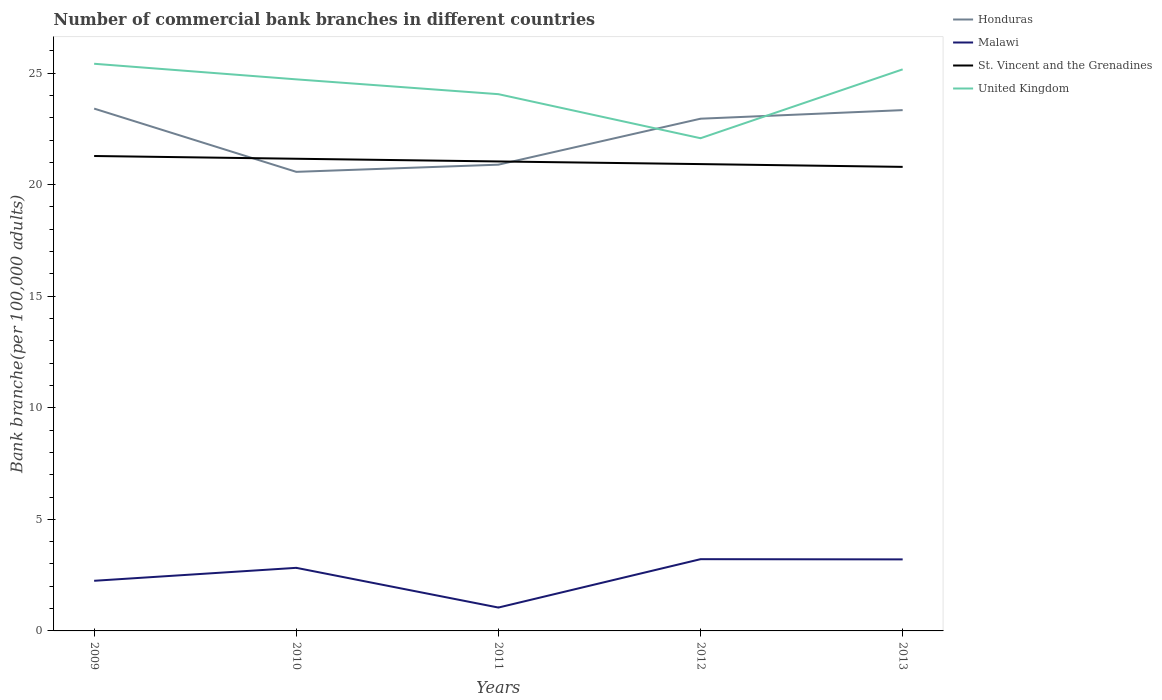Does the line corresponding to United Kingdom intersect with the line corresponding to Malawi?
Offer a very short reply. No. Across all years, what is the maximum number of commercial bank branches in Honduras?
Provide a succinct answer. 20.57. What is the total number of commercial bank branches in St. Vincent and the Grenadines in the graph?
Your answer should be compact. 0.24. What is the difference between the highest and the second highest number of commercial bank branches in United Kingdom?
Provide a succinct answer. 3.34. What is the difference between the highest and the lowest number of commercial bank branches in Honduras?
Provide a succinct answer. 3. Is the number of commercial bank branches in St. Vincent and the Grenadines strictly greater than the number of commercial bank branches in Malawi over the years?
Give a very brief answer. No. How many lines are there?
Your answer should be very brief. 4. What is the difference between two consecutive major ticks on the Y-axis?
Offer a terse response. 5. Are the values on the major ticks of Y-axis written in scientific E-notation?
Keep it short and to the point. No. Does the graph contain grids?
Your answer should be very brief. No. What is the title of the graph?
Provide a succinct answer. Number of commercial bank branches in different countries. Does "Estonia" appear as one of the legend labels in the graph?
Provide a short and direct response. No. What is the label or title of the X-axis?
Ensure brevity in your answer.  Years. What is the label or title of the Y-axis?
Offer a very short reply. Bank branche(per 100,0 adults). What is the Bank branche(per 100,000 adults) of Honduras in 2009?
Provide a succinct answer. 23.41. What is the Bank branche(per 100,000 adults) of Malawi in 2009?
Offer a very short reply. 2.25. What is the Bank branche(per 100,000 adults) in St. Vincent and the Grenadines in 2009?
Offer a terse response. 21.28. What is the Bank branche(per 100,000 adults) in United Kingdom in 2009?
Your answer should be compact. 25.42. What is the Bank branche(per 100,000 adults) of Honduras in 2010?
Make the answer very short. 20.57. What is the Bank branche(per 100,000 adults) of Malawi in 2010?
Your answer should be very brief. 2.83. What is the Bank branche(per 100,000 adults) of St. Vincent and the Grenadines in 2010?
Provide a succinct answer. 21.16. What is the Bank branche(per 100,000 adults) of United Kingdom in 2010?
Offer a terse response. 24.72. What is the Bank branche(per 100,000 adults) of Honduras in 2011?
Offer a terse response. 20.89. What is the Bank branche(per 100,000 adults) of Malawi in 2011?
Provide a short and direct response. 1.05. What is the Bank branche(per 100,000 adults) of St. Vincent and the Grenadines in 2011?
Your response must be concise. 21.04. What is the Bank branche(per 100,000 adults) in United Kingdom in 2011?
Make the answer very short. 24.05. What is the Bank branche(per 100,000 adults) of Honduras in 2012?
Ensure brevity in your answer.  22.95. What is the Bank branche(per 100,000 adults) of Malawi in 2012?
Provide a short and direct response. 3.22. What is the Bank branche(per 100,000 adults) in St. Vincent and the Grenadines in 2012?
Offer a very short reply. 20.92. What is the Bank branche(per 100,000 adults) in United Kingdom in 2012?
Provide a short and direct response. 22.08. What is the Bank branche(per 100,000 adults) in Honduras in 2013?
Provide a succinct answer. 23.34. What is the Bank branche(per 100,000 adults) in Malawi in 2013?
Provide a short and direct response. 3.21. What is the Bank branche(per 100,000 adults) of St. Vincent and the Grenadines in 2013?
Make the answer very short. 20.8. What is the Bank branche(per 100,000 adults) in United Kingdom in 2013?
Your response must be concise. 25.17. Across all years, what is the maximum Bank branche(per 100,000 adults) of Honduras?
Offer a very short reply. 23.41. Across all years, what is the maximum Bank branche(per 100,000 adults) of Malawi?
Offer a very short reply. 3.22. Across all years, what is the maximum Bank branche(per 100,000 adults) of St. Vincent and the Grenadines?
Your answer should be compact. 21.28. Across all years, what is the maximum Bank branche(per 100,000 adults) of United Kingdom?
Keep it short and to the point. 25.42. Across all years, what is the minimum Bank branche(per 100,000 adults) in Honduras?
Provide a short and direct response. 20.57. Across all years, what is the minimum Bank branche(per 100,000 adults) in Malawi?
Your answer should be compact. 1.05. Across all years, what is the minimum Bank branche(per 100,000 adults) in St. Vincent and the Grenadines?
Your answer should be very brief. 20.8. Across all years, what is the minimum Bank branche(per 100,000 adults) of United Kingdom?
Your answer should be very brief. 22.08. What is the total Bank branche(per 100,000 adults) of Honduras in the graph?
Provide a succinct answer. 111.17. What is the total Bank branche(per 100,000 adults) in Malawi in the graph?
Ensure brevity in your answer.  12.54. What is the total Bank branche(per 100,000 adults) in St. Vincent and the Grenadines in the graph?
Your answer should be very brief. 105.2. What is the total Bank branche(per 100,000 adults) in United Kingdom in the graph?
Ensure brevity in your answer.  121.44. What is the difference between the Bank branche(per 100,000 adults) in Honduras in 2009 and that in 2010?
Your response must be concise. 2.83. What is the difference between the Bank branche(per 100,000 adults) of Malawi in 2009 and that in 2010?
Offer a terse response. -0.58. What is the difference between the Bank branche(per 100,000 adults) of St. Vincent and the Grenadines in 2009 and that in 2010?
Your response must be concise. 0.12. What is the difference between the Bank branche(per 100,000 adults) in United Kingdom in 2009 and that in 2010?
Provide a succinct answer. 0.7. What is the difference between the Bank branche(per 100,000 adults) of Honduras in 2009 and that in 2011?
Provide a short and direct response. 2.51. What is the difference between the Bank branche(per 100,000 adults) in Malawi in 2009 and that in 2011?
Your answer should be very brief. 1.2. What is the difference between the Bank branche(per 100,000 adults) of St. Vincent and the Grenadines in 2009 and that in 2011?
Make the answer very short. 0.24. What is the difference between the Bank branche(per 100,000 adults) in United Kingdom in 2009 and that in 2011?
Your answer should be very brief. 1.36. What is the difference between the Bank branche(per 100,000 adults) of Honduras in 2009 and that in 2012?
Your answer should be very brief. 0.45. What is the difference between the Bank branche(per 100,000 adults) in Malawi in 2009 and that in 2012?
Keep it short and to the point. -0.97. What is the difference between the Bank branche(per 100,000 adults) in St. Vincent and the Grenadines in 2009 and that in 2012?
Your answer should be very brief. 0.36. What is the difference between the Bank branche(per 100,000 adults) of United Kingdom in 2009 and that in 2012?
Your answer should be compact. 3.34. What is the difference between the Bank branche(per 100,000 adults) in Honduras in 2009 and that in 2013?
Make the answer very short. 0.07. What is the difference between the Bank branche(per 100,000 adults) in Malawi in 2009 and that in 2013?
Provide a succinct answer. -0.96. What is the difference between the Bank branche(per 100,000 adults) of St. Vincent and the Grenadines in 2009 and that in 2013?
Ensure brevity in your answer.  0.49. What is the difference between the Bank branche(per 100,000 adults) in United Kingdom in 2009 and that in 2013?
Provide a succinct answer. 0.25. What is the difference between the Bank branche(per 100,000 adults) of Honduras in 2010 and that in 2011?
Keep it short and to the point. -0.32. What is the difference between the Bank branche(per 100,000 adults) in Malawi in 2010 and that in 2011?
Ensure brevity in your answer.  1.78. What is the difference between the Bank branche(per 100,000 adults) in St. Vincent and the Grenadines in 2010 and that in 2011?
Ensure brevity in your answer.  0.12. What is the difference between the Bank branche(per 100,000 adults) in United Kingdom in 2010 and that in 2011?
Make the answer very short. 0.66. What is the difference between the Bank branche(per 100,000 adults) of Honduras in 2010 and that in 2012?
Keep it short and to the point. -2.38. What is the difference between the Bank branche(per 100,000 adults) of Malawi in 2010 and that in 2012?
Your response must be concise. -0.39. What is the difference between the Bank branche(per 100,000 adults) of St. Vincent and the Grenadines in 2010 and that in 2012?
Offer a very short reply. 0.24. What is the difference between the Bank branche(per 100,000 adults) in United Kingdom in 2010 and that in 2012?
Keep it short and to the point. 2.64. What is the difference between the Bank branche(per 100,000 adults) of Honduras in 2010 and that in 2013?
Make the answer very short. -2.77. What is the difference between the Bank branche(per 100,000 adults) in Malawi in 2010 and that in 2013?
Offer a terse response. -0.38. What is the difference between the Bank branche(per 100,000 adults) in St. Vincent and the Grenadines in 2010 and that in 2013?
Provide a succinct answer. 0.36. What is the difference between the Bank branche(per 100,000 adults) in United Kingdom in 2010 and that in 2013?
Keep it short and to the point. -0.45. What is the difference between the Bank branche(per 100,000 adults) in Honduras in 2011 and that in 2012?
Ensure brevity in your answer.  -2.06. What is the difference between the Bank branche(per 100,000 adults) in Malawi in 2011 and that in 2012?
Offer a very short reply. -2.17. What is the difference between the Bank branche(per 100,000 adults) of St. Vincent and the Grenadines in 2011 and that in 2012?
Your answer should be very brief. 0.12. What is the difference between the Bank branche(per 100,000 adults) in United Kingdom in 2011 and that in 2012?
Your answer should be compact. 1.97. What is the difference between the Bank branche(per 100,000 adults) in Honduras in 2011 and that in 2013?
Your answer should be very brief. -2.44. What is the difference between the Bank branche(per 100,000 adults) of Malawi in 2011 and that in 2013?
Make the answer very short. -2.16. What is the difference between the Bank branche(per 100,000 adults) of St. Vincent and the Grenadines in 2011 and that in 2013?
Provide a succinct answer. 0.24. What is the difference between the Bank branche(per 100,000 adults) of United Kingdom in 2011 and that in 2013?
Provide a short and direct response. -1.11. What is the difference between the Bank branche(per 100,000 adults) of Honduras in 2012 and that in 2013?
Your response must be concise. -0.38. What is the difference between the Bank branche(per 100,000 adults) of Malawi in 2012 and that in 2013?
Keep it short and to the point. 0.01. What is the difference between the Bank branche(per 100,000 adults) of St. Vincent and the Grenadines in 2012 and that in 2013?
Your answer should be compact. 0.12. What is the difference between the Bank branche(per 100,000 adults) of United Kingdom in 2012 and that in 2013?
Provide a short and direct response. -3.09. What is the difference between the Bank branche(per 100,000 adults) of Honduras in 2009 and the Bank branche(per 100,000 adults) of Malawi in 2010?
Ensure brevity in your answer.  20.58. What is the difference between the Bank branche(per 100,000 adults) of Honduras in 2009 and the Bank branche(per 100,000 adults) of St. Vincent and the Grenadines in 2010?
Give a very brief answer. 2.25. What is the difference between the Bank branche(per 100,000 adults) in Honduras in 2009 and the Bank branche(per 100,000 adults) in United Kingdom in 2010?
Offer a very short reply. -1.31. What is the difference between the Bank branche(per 100,000 adults) of Malawi in 2009 and the Bank branche(per 100,000 adults) of St. Vincent and the Grenadines in 2010?
Your answer should be compact. -18.91. What is the difference between the Bank branche(per 100,000 adults) in Malawi in 2009 and the Bank branche(per 100,000 adults) in United Kingdom in 2010?
Provide a succinct answer. -22.47. What is the difference between the Bank branche(per 100,000 adults) in St. Vincent and the Grenadines in 2009 and the Bank branche(per 100,000 adults) in United Kingdom in 2010?
Provide a succinct answer. -3.44. What is the difference between the Bank branche(per 100,000 adults) of Honduras in 2009 and the Bank branche(per 100,000 adults) of Malawi in 2011?
Your answer should be compact. 22.36. What is the difference between the Bank branche(per 100,000 adults) in Honduras in 2009 and the Bank branche(per 100,000 adults) in St. Vincent and the Grenadines in 2011?
Your answer should be compact. 2.37. What is the difference between the Bank branche(per 100,000 adults) of Honduras in 2009 and the Bank branche(per 100,000 adults) of United Kingdom in 2011?
Provide a succinct answer. -0.65. What is the difference between the Bank branche(per 100,000 adults) in Malawi in 2009 and the Bank branche(per 100,000 adults) in St. Vincent and the Grenadines in 2011?
Give a very brief answer. -18.79. What is the difference between the Bank branche(per 100,000 adults) in Malawi in 2009 and the Bank branche(per 100,000 adults) in United Kingdom in 2011?
Ensure brevity in your answer.  -21.81. What is the difference between the Bank branche(per 100,000 adults) in St. Vincent and the Grenadines in 2009 and the Bank branche(per 100,000 adults) in United Kingdom in 2011?
Make the answer very short. -2.77. What is the difference between the Bank branche(per 100,000 adults) in Honduras in 2009 and the Bank branche(per 100,000 adults) in Malawi in 2012?
Offer a very short reply. 20.19. What is the difference between the Bank branche(per 100,000 adults) in Honduras in 2009 and the Bank branche(per 100,000 adults) in St. Vincent and the Grenadines in 2012?
Give a very brief answer. 2.49. What is the difference between the Bank branche(per 100,000 adults) in Honduras in 2009 and the Bank branche(per 100,000 adults) in United Kingdom in 2012?
Keep it short and to the point. 1.33. What is the difference between the Bank branche(per 100,000 adults) in Malawi in 2009 and the Bank branche(per 100,000 adults) in St. Vincent and the Grenadines in 2012?
Your response must be concise. -18.67. What is the difference between the Bank branche(per 100,000 adults) in Malawi in 2009 and the Bank branche(per 100,000 adults) in United Kingdom in 2012?
Make the answer very short. -19.83. What is the difference between the Bank branche(per 100,000 adults) in St. Vincent and the Grenadines in 2009 and the Bank branche(per 100,000 adults) in United Kingdom in 2012?
Your response must be concise. -0.8. What is the difference between the Bank branche(per 100,000 adults) in Honduras in 2009 and the Bank branche(per 100,000 adults) in Malawi in 2013?
Your answer should be very brief. 20.2. What is the difference between the Bank branche(per 100,000 adults) in Honduras in 2009 and the Bank branche(per 100,000 adults) in St. Vincent and the Grenadines in 2013?
Your answer should be very brief. 2.61. What is the difference between the Bank branche(per 100,000 adults) in Honduras in 2009 and the Bank branche(per 100,000 adults) in United Kingdom in 2013?
Your answer should be compact. -1.76. What is the difference between the Bank branche(per 100,000 adults) of Malawi in 2009 and the Bank branche(per 100,000 adults) of St. Vincent and the Grenadines in 2013?
Your answer should be very brief. -18.55. What is the difference between the Bank branche(per 100,000 adults) of Malawi in 2009 and the Bank branche(per 100,000 adults) of United Kingdom in 2013?
Ensure brevity in your answer.  -22.92. What is the difference between the Bank branche(per 100,000 adults) in St. Vincent and the Grenadines in 2009 and the Bank branche(per 100,000 adults) in United Kingdom in 2013?
Provide a short and direct response. -3.88. What is the difference between the Bank branche(per 100,000 adults) of Honduras in 2010 and the Bank branche(per 100,000 adults) of Malawi in 2011?
Ensure brevity in your answer.  19.53. What is the difference between the Bank branche(per 100,000 adults) in Honduras in 2010 and the Bank branche(per 100,000 adults) in St. Vincent and the Grenadines in 2011?
Keep it short and to the point. -0.47. What is the difference between the Bank branche(per 100,000 adults) of Honduras in 2010 and the Bank branche(per 100,000 adults) of United Kingdom in 2011?
Offer a very short reply. -3.48. What is the difference between the Bank branche(per 100,000 adults) in Malawi in 2010 and the Bank branche(per 100,000 adults) in St. Vincent and the Grenadines in 2011?
Your answer should be compact. -18.21. What is the difference between the Bank branche(per 100,000 adults) of Malawi in 2010 and the Bank branche(per 100,000 adults) of United Kingdom in 2011?
Provide a succinct answer. -21.23. What is the difference between the Bank branche(per 100,000 adults) of St. Vincent and the Grenadines in 2010 and the Bank branche(per 100,000 adults) of United Kingdom in 2011?
Your answer should be very brief. -2.89. What is the difference between the Bank branche(per 100,000 adults) in Honduras in 2010 and the Bank branche(per 100,000 adults) in Malawi in 2012?
Your answer should be compact. 17.36. What is the difference between the Bank branche(per 100,000 adults) in Honduras in 2010 and the Bank branche(per 100,000 adults) in St. Vincent and the Grenadines in 2012?
Offer a terse response. -0.35. What is the difference between the Bank branche(per 100,000 adults) of Honduras in 2010 and the Bank branche(per 100,000 adults) of United Kingdom in 2012?
Give a very brief answer. -1.51. What is the difference between the Bank branche(per 100,000 adults) in Malawi in 2010 and the Bank branche(per 100,000 adults) in St. Vincent and the Grenadines in 2012?
Ensure brevity in your answer.  -18.09. What is the difference between the Bank branche(per 100,000 adults) of Malawi in 2010 and the Bank branche(per 100,000 adults) of United Kingdom in 2012?
Offer a terse response. -19.25. What is the difference between the Bank branche(per 100,000 adults) in St. Vincent and the Grenadines in 2010 and the Bank branche(per 100,000 adults) in United Kingdom in 2012?
Keep it short and to the point. -0.92. What is the difference between the Bank branche(per 100,000 adults) of Honduras in 2010 and the Bank branche(per 100,000 adults) of Malawi in 2013?
Your response must be concise. 17.37. What is the difference between the Bank branche(per 100,000 adults) of Honduras in 2010 and the Bank branche(per 100,000 adults) of St. Vincent and the Grenadines in 2013?
Provide a succinct answer. -0.22. What is the difference between the Bank branche(per 100,000 adults) in Honduras in 2010 and the Bank branche(per 100,000 adults) in United Kingdom in 2013?
Your answer should be very brief. -4.59. What is the difference between the Bank branche(per 100,000 adults) in Malawi in 2010 and the Bank branche(per 100,000 adults) in St. Vincent and the Grenadines in 2013?
Give a very brief answer. -17.97. What is the difference between the Bank branche(per 100,000 adults) in Malawi in 2010 and the Bank branche(per 100,000 adults) in United Kingdom in 2013?
Make the answer very short. -22.34. What is the difference between the Bank branche(per 100,000 adults) in St. Vincent and the Grenadines in 2010 and the Bank branche(per 100,000 adults) in United Kingdom in 2013?
Make the answer very short. -4.01. What is the difference between the Bank branche(per 100,000 adults) in Honduras in 2011 and the Bank branche(per 100,000 adults) in Malawi in 2012?
Provide a short and direct response. 17.68. What is the difference between the Bank branche(per 100,000 adults) in Honduras in 2011 and the Bank branche(per 100,000 adults) in St. Vincent and the Grenadines in 2012?
Offer a terse response. -0.03. What is the difference between the Bank branche(per 100,000 adults) of Honduras in 2011 and the Bank branche(per 100,000 adults) of United Kingdom in 2012?
Your answer should be very brief. -1.19. What is the difference between the Bank branche(per 100,000 adults) in Malawi in 2011 and the Bank branche(per 100,000 adults) in St. Vincent and the Grenadines in 2012?
Your answer should be compact. -19.87. What is the difference between the Bank branche(per 100,000 adults) in Malawi in 2011 and the Bank branche(per 100,000 adults) in United Kingdom in 2012?
Make the answer very short. -21.03. What is the difference between the Bank branche(per 100,000 adults) in St. Vincent and the Grenadines in 2011 and the Bank branche(per 100,000 adults) in United Kingdom in 2012?
Make the answer very short. -1.04. What is the difference between the Bank branche(per 100,000 adults) in Honduras in 2011 and the Bank branche(per 100,000 adults) in Malawi in 2013?
Offer a terse response. 17.69. What is the difference between the Bank branche(per 100,000 adults) in Honduras in 2011 and the Bank branche(per 100,000 adults) in St. Vincent and the Grenadines in 2013?
Give a very brief answer. 0.1. What is the difference between the Bank branche(per 100,000 adults) of Honduras in 2011 and the Bank branche(per 100,000 adults) of United Kingdom in 2013?
Give a very brief answer. -4.27. What is the difference between the Bank branche(per 100,000 adults) of Malawi in 2011 and the Bank branche(per 100,000 adults) of St. Vincent and the Grenadines in 2013?
Offer a very short reply. -19.75. What is the difference between the Bank branche(per 100,000 adults) in Malawi in 2011 and the Bank branche(per 100,000 adults) in United Kingdom in 2013?
Give a very brief answer. -24.12. What is the difference between the Bank branche(per 100,000 adults) of St. Vincent and the Grenadines in 2011 and the Bank branche(per 100,000 adults) of United Kingdom in 2013?
Ensure brevity in your answer.  -4.13. What is the difference between the Bank branche(per 100,000 adults) of Honduras in 2012 and the Bank branche(per 100,000 adults) of Malawi in 2013?
Keep it short and to the point. 19.75. What is the difference between the Bank branche(per 100,000 adults) in Honduras in 2012 and the Bank branche(per 100,000 adults) in St. Vincent and the Grenadines in 2013?
Keep it short and to the point. 2.16. What is the difference between the Bank branche(per 100,000 adults) of Honduras in 2012 and the Bank branche(per 100,000 adults) of United Kingdom in 2013?
Ensure brevity in your answer.  -2.21. What is the difference between the Bank branche(per 100,000 adults) in Malawi in 2012 and the Bank branche(per 100,000 adults) in St. Vincent and the Grenadines in 2013?
Offer a very short reply. -17.58. What is the difference between the Bank branche(per 100,000 adults) in Malawi in 2012 and the Bank branche(per 100,000 adults) in United Kingdom in 2013?
Ensure brevity in your answer.  -21.95. What is the difference between the Bank branche(per 100,000 adults) in St. Vincent and the Grenadines in 2012 and the Bank branche(per 100,000 adults) in United Kingdom in 2013?
Provide a short and direct response. -4.25. What is the average Bank branche(per 100,000 adults) in Honduras per year?
Provide a short and direct response. 22.23. What is the average Bank branche(per 100,000 adults) in Malawi per year?
Offer a terse response. 2.51. What is the average Bank branche(per 100,000 adults) of St. Vincent and the Grenadines per year?
Offer a very short reply. 21.04. What is the average Bank branche(per 100,000 adults) of United Kingdom per year?
Make the answer very short. 24.29. In the year 2009, what is the difference between the Bank branche(per 100,000 adults) in Honduras and Bank branche(per 100,000 adults) in Malawi?
Ensure brevity in your answer.  21.16. In the year 2009, what is the difference between the Bank branche(per 100,000 adults) in Honduras and Bank branche(per 100,000 adults) in St. Vincent and the Grenadines?
Your answer should be compact. 2.12. In the year 2009, what is the difference between the Bank branche(per 100,000 adults) in Honduras and Bank branche(per 100,000 adults) in United Kingdom?
Keep it short and to the point. -2.01. In the year 2009, what is the difference between the Bank branche(per 100,000 adults) in Malawi and Bank branche(per 100,000 adults) in St. Vincent and the Grenadines?
Provide a succinct answer. -19.04. In the year 2009, what is the difference between the Bank branche(per 100,000 adults) of Malawi and Bank branche(per 100,000 adults) of United Kingdom?
Provide a succinct answer. -23.17. In the year 2009, what is the difference between the Bank branche(per 100,000 adults) in St. Vincent and the Grenadines and Bank branche(per 100,000 adults) in United Kingdom?
Provide a short and direct response. -4.13. In the year 2010, what is the difference between the Bank branche(per 100,000 adults) in Honduras and Bank branche(per 100,000 adults) in Malawi?
Ensure brevity in your answer.  17.75. In the year 2010, what is the difference between the Bank branche(per 100,000 adults) of Honduras and Bank branche(per 100,000 adults) of St. Vincent and the Grenadines?
Provide a succinct answer. -0.59. In the year 2010, what is the difference between the Bank branche(per 100,000 adults) of Honduras and Bank branche(per 100,000 adults) of United Kingdom?
Give a very brief answer. -4.15. In the year 2010, what is the difference between the Bank branche(per 100,000 adults) in Malawi and Bank branche(per 100,000 adults) in St. Vincent and the Grenadines?
Give a very brief answer. -18.33. In the year 2010, what is the difference between the Bank branche(per 100,000 adults) in Malawi and Bank branche(per 100,000 adults) in United Kingdom?
Your answer should be compact. -21.89. In the year 2010, what is the difference between the Bank branche(per 100,000 adults) in St. Vincent and the Grenadines and Bank branche(per 100,000 adults) in United Kingdom?
Make the answer very short. -3.56. In the year 2011, what is the difference between the Bank branche(per 100,000 adults) of Honduras and Bank branche(per 100,000 adults) of Malawi?
Your response must be concise. 19.85. In the year 2011, what is the difference between the Bank branche(per 100,000 adults) of Honduras and Bank branche(per 100,000 adults) of St. Vincent and the Grenadines?
Make the answer very short. -0.14. In the year 2011, what is the difference between the Bank branche(per 100,000 adults) in Honduras and Bank branche(per 100,000 adults) in United Kingdom?
Offer a very short reply. -3.16. In the year 2011, what is the difference between the Bank branche(per 100,000 adults) of Malawi and Bank branche(per 100,000 adults) of St. Vincent and the Grenadines?
Your answer should be compact. -19.99. In the year 2011, what is the difference between the Bank branche(per 100,000 adults) in Malawi and Bank branche(per 100,000 adults) in United Kingdom?
Make the answer very short. -23.01. In the year 2011, what is the difference between the Bank branche(per 100,000 adults) in St. Vincent and the Grenadines and Bank branche(per 100,000 adults) in United Kingdom?
Your answer should be compact. -3.02. In the year 2012, what is the difference between the Bank branche(per 100,000 adults) in Honduras and Bank branche(per 100,000 adults) in Malawi?
Keep it short and to the point. 19.74. In the year 2012, what is the difference between the Bank branche(per 100,000 adults) of Honduras and Bank branche(per 100,000 adults) of St. Vincent and the Grenadines?
Your answer should be compact. 2.03. In the year 2012, what is the difference between the Bank branche(per 100,000 adults) in Malawi and Bank branche(per 100,000 adults) in St. Vincent and the Grenadines?
Offer a very short reply. -17.71. In the year 2012, what is the difference between the Bank branche(per 100,000 adults) in Malawi and Bank branche(per 100,000 adults) in United Kingdom?
Your answer should be very brief. -18.86. In the year 2012, what is the difference between the Bank branche(per 100,000 adults) of St. Vincent and the Grenadines and Bank branche(per 100,000 adults) of United Kingdom?
Your response must be concise. -1.16. In the year 2013, what is the difference between the Bank branche(per 100,000 adults) in Honduras and Bank branche(per 100,000 adults) in Malawi?
Keep it short and to the point. 20.13. In the year 2013, what is the difference between the Bank branche(per 100,000 adults) in Honduras and Bank branche(per 100,000 adults) in St. Vincent and the Grenadines?
Offer a very short reply. 2.54. In the year 2013, what is the difference between the Bank branche(per 100,000 adults) of Honduras and Bank branche(per 100,000 adults) of United Kingdom?
Ensure brevity in your answer.  -1.83. In the year 2013, what is the difference between the Bank branche(per 100,000 adults) of Malawi and Bank branche(per 100,000 adults) of St. Vincent and the Grenadines?
Ensure brevity in your answer.  -17.59. In the year 2013, what is the difference between the Bank branche(per 100,000 adults) in Malawi and Bank branche(per 100,000 adults) in United Kingdom?
Give a very brief answer. -21.96. In the year 2013, what is the difference between the Bank branche(per 100,000 adults) of St. Vincent and the Grenadines and Bank branche(per 100,000 adults) of United Kingdom?
Keep it short and to the point. -4.37. What is the ratio of the Bank branche(per 100,000 adults) of Honduras in 2009 to that in 2010?
Your answer should be compact. 1.14. What is the ratio of the Bank branche(per 100,000 adults) in Malawi in 2009 to that in 2010?
Offer a terse response. 0.79. What is the ratio of the Bank branche(per 100,000 adults) in United Kingdom in 2009 to that in 2010?
Ensure brevity in your answer.  1.03. What is the ratio of the Bank branche(per 100,000 adults) of Honduras in 2009 to that in 2011?
Provide a short and direct response. 1.12. What is the ratio of the Bank branche(per 100,000 adults) in Malawi in 2009 to that in 2011?
Your response must be concise. 2.14. What is the ratio of the Bank branche(per 100,000 adults) in St. Vincent and the Grenadines in 2009 to that in 2011?
Offer a terse response. 1.01. What is the ratio of the Bank branche(per 100,000 adults) of United Kingdom in 2009 to that in 2011?
Provide a short and direct response. 1.06. What is the ratio of the Bank branche(per 100,000 adults) of Honduras in 2009 to that in 2012?
Offer a very short reply. 1.02. What is the ratio of the Bank branche(per 100,000 adults) of Malawi in 2009 to that in 2012?
Make the answer very short. 0.7. What is the ratio of the Bank branche(per 100,000 adults) in St. Vincent and the Grenadines in 2009 to that in 2012?
Keep it short and to the point. 1.02. What is the ratio of the Bank branche(per 100,000 adults) in United Kingdom in 2009 to that in 2012?
Make the answer very short. 1.15. What is the ratio of the Bank branche(per 100,000 adults) of Malawi in 2009 to that in 2013?
Provide a succinct answer. 0.7. What is the ratio of the Bank branche(per 100,000 adults) in St. Vincent and the Grenadines in 2009 to that in 2013?
Offer a very short reply. 1.02. What is the ratio of the Bank branche(per 100,000 adults) in United Kingdom in 2009 to that in 2013?
Offer a terse response. 1.01. What is the ratio of the Bank branche(per 100,000 adults) in Honduras in 2010 to that in 2011?
Your answer should be compact. 0.98. What is the ratio of the Bank branche(per 100,000 adults) in Malawi in 2010 to that in 2011?
Your response must be concise. 2.7. What is the ratio of the Bank branche(per 100,000 adults) of United Kingdom in 2010 to that in 2011?
Make the answer very short. 1.03. What is the ratio of the Bank branche(per 100,000 adults) in Honduras in 2010 to that in 2012?
Offer a terse response. 0.9. What is the ratio of the Bank branche(per 100,000 adults) of Malawi in 2010 to that in 2012?
Provide a succinct answer. 0.88. What is the ratio of the Bank branche(per 100,000 adults) in St. Vincent and the Grenadines in 2010 to that in 2012?
Keep it short and to the point. 1.01. What is the ratio of the Bank branche(per 100,000 adults) of United Kingdom in 2010 to that in 2012?
Your answer should be very brief. 1.12. What is the ratio of the Bank branche(per 100,000 adults) in Honduras in 2010 to that in 2013?
Provide a succinct answer. 0.88. What is the ratio of the Bank branche(per 100,000 adults) of Malawi in 2010 to that in 2013?
Your answer should be compact. 0.88. What is the ratio of the Bank branche(per 100,000 adults) in St. Vincent and the Grenadines in 2010 to that in 2013?
Your answer should be compact. 1.02. What is the ratio of the Bank branche(per 100,000 adults) in United Kingdom in 2010 to that in 2013?
Your answer should be very brief. 0.98. What is the ratio of the Bank branche(per 100,000 adults) in Honduras in 2011 to that in 2012?
Offer a very short reply. 0.91. What is the ratio of the Bank branche(per 100,000 adults) in Malawi in 2011 to that in 2012?
Your answer should be very brief. 0.33. What is the ratio of the Bank branche(per 100,000 adults) in St. Vincent and the Grenadines in 2011 to that in 2012?
Provide a succinct answer. 1.01. What is the ratio of the Bank branche(per 100,000 adults) in United Kingdom in 2011 to that in 2012?
Give a very brief answer. 1.09. What is the ratio of the Bank branche(per 100,000 adults) in Honduras in 2011 to that in 2013?
Ensure brevity in your answer.  0.9. What is the ratio of the Bank branche(per 100,000 adults) of Malawi in 2011 to that in 2013?
Offer a terse response. 0.33. What is the ratio of the Bank branche(per 100,000 adults) in St. Vincent and the Grenadines in 2011 to that in 2013?
Make the answer very short. 1.01. What is the ratio of the Bank branche(per 100,000 adults) of United Kingdom in 2011 to that in 2013?
Keep it short and to the point. 0.96. What is the ratio of the Bank branche(per 100,000 adults) in Honduras in 2012 to that in 2013?
Provide a short and direct response. 0.98. What is the ratio of the Bank branche(per 100,000 adults) of United Kingdom in 2012 to that in 2013?
Your answer should be compact. 0.88. What is the difference between the highest and the second highest Bank branche(per 100,000 adults) in Honduras?
Your answer should be compact. 0.07. What is the difference between the highest and the second highest Bank branche(per 100,000 adults) in Malawi?
Offer a terse response. 0.01. What is the difference between the highest and the second highest Bank branche(per 100,000 adults) in St. Vincent and the Grenadines?
Ensure brevity in your answer.  0.12. What is the difference between the highest and the second highest Bank branche(per 100,000 adults) of United Kingdom?
Your answer should be compact. 0.25. What is the difference between the highest and the lowest Bank branche(per 100,000 adults) in Honduras?
Provide a short and direct response. 2.83. What is the difference between the highest and the lowest Bank branche(per 100,000 adults) of Malawi?
Give a very brief answer. 2.17. What is the difference between the highest and the lowest Bank branche(per 100,000 adults) of St. Vincent and the Grenadines?
Make the answer very short. 0.49. What is the difference between the highest and the lowest Bank branche(per 100,000 adults) in United Kingdom?
Your answer should be compact. 3.34. 